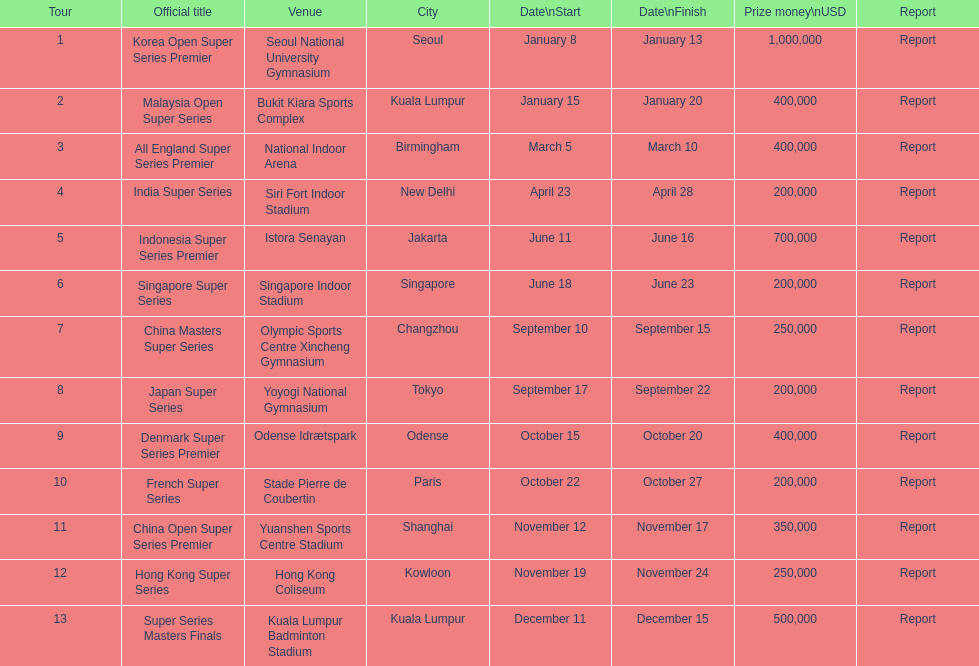How many take place in the last half of the year? 7. 